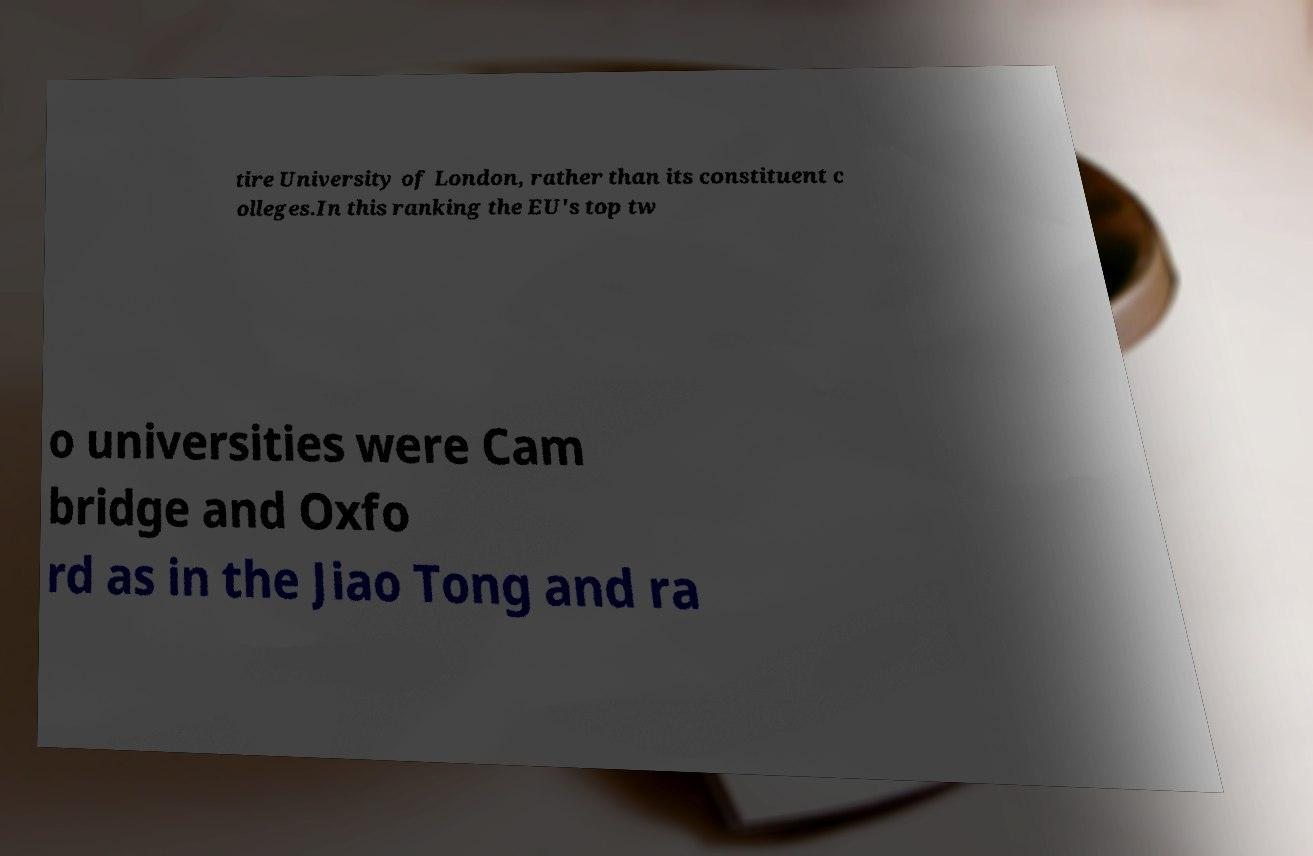Can you accurately transcribe the text from the provided image for me? tire University of London, rather than its constituent c olleges.In this ranking the EU's top tw o universities were Cam bridge and Oxfo rd as in the Jiao Tong and ra 